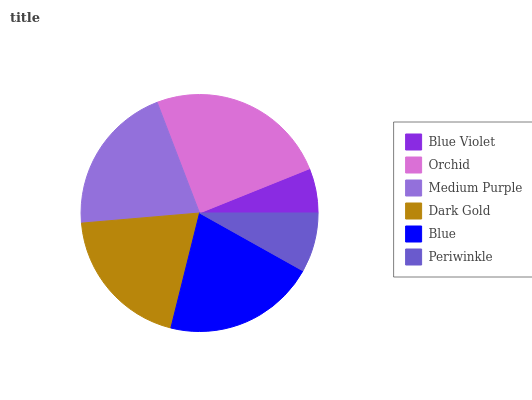Is Blue Violet the minimum?
Answer yes or no. Yes. Is Orchid the maximum?
Answer yes or no. Yes. Is Medium Purple the minimum?
Answer yes or no. No. Is Medium Purple the maximum?
Answer yes or no. No. Is Orchid greater than Medium Purple?
Answer yes or no. Yes. Is Medium Purple less than Orchid?
Answer yes or no. Yes. Is Medium Purple greater than Orchid?
Answer yes or no. No. Is Orchid less than Medium Purple?
Answer yes or no. No. Is Medium Purple the high median?
Answer yes or no. Yes. Is Dark Gold the low median?
Answer yes or no. Yes. Is Orchid the high median?
Answer yes or no. No. Is Periwinkle the low median?
Answer yes or no. No. 